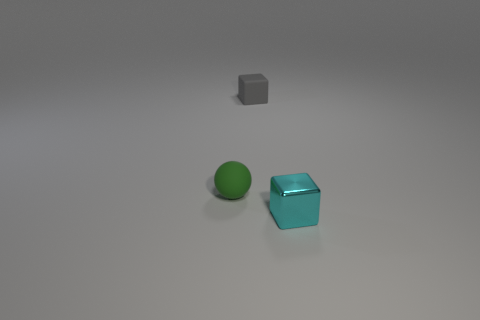Add 3 metallic things. How many objects exist? 6 Subtract all spheres. How many objects are left? 2 Add 1 shiny objects. How many shiny objects are left? 2 Add 1 small cyan things. How many small cyan things exist? 2 Subtract 0 blue spheres. How many objects are left? 3 Subtract all balls. Subtract all small matte cubes. How many objects are left? 1 